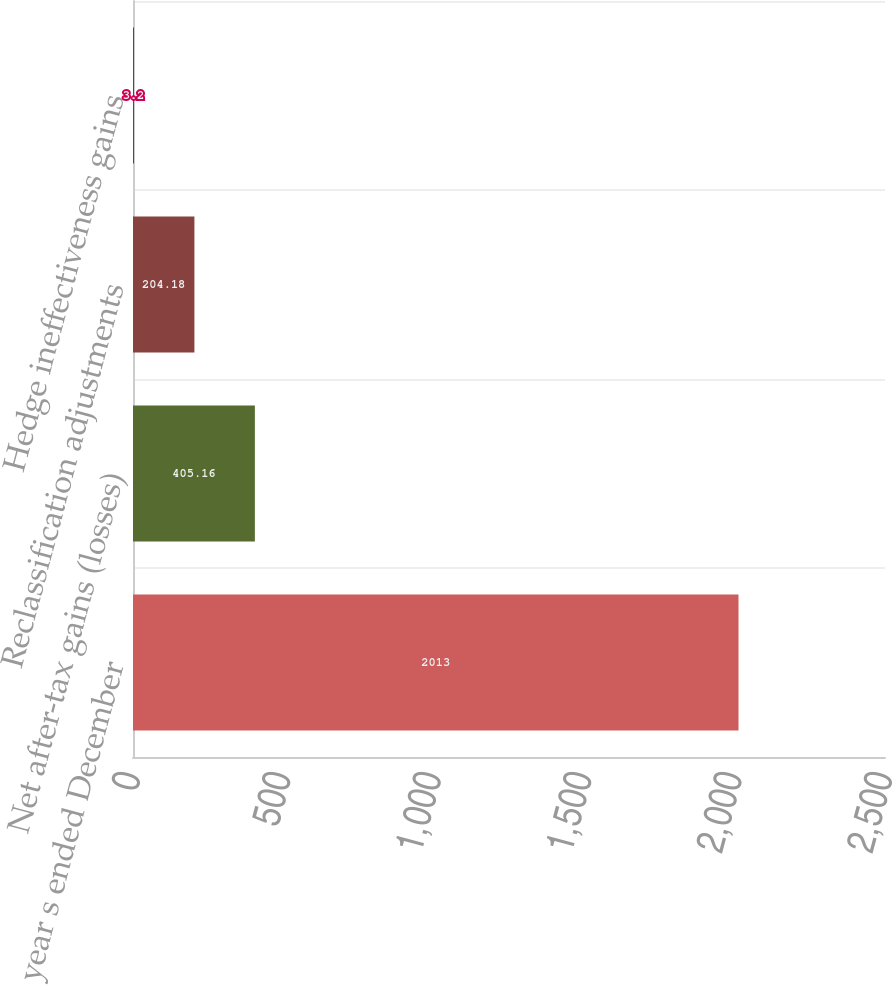<chart> <loc_0><loc_0><loc_500><loc_500><bar_chart><fcel>For the year s ended December<fcel>Net after-tax gains (losses)<fcel>Reclassification adjustments<fcel>Hedge ineffectiveness gains<nl><fcel>2013<fcel>405.16<fcel>204.18<fcel>3.2<nl></chart> 